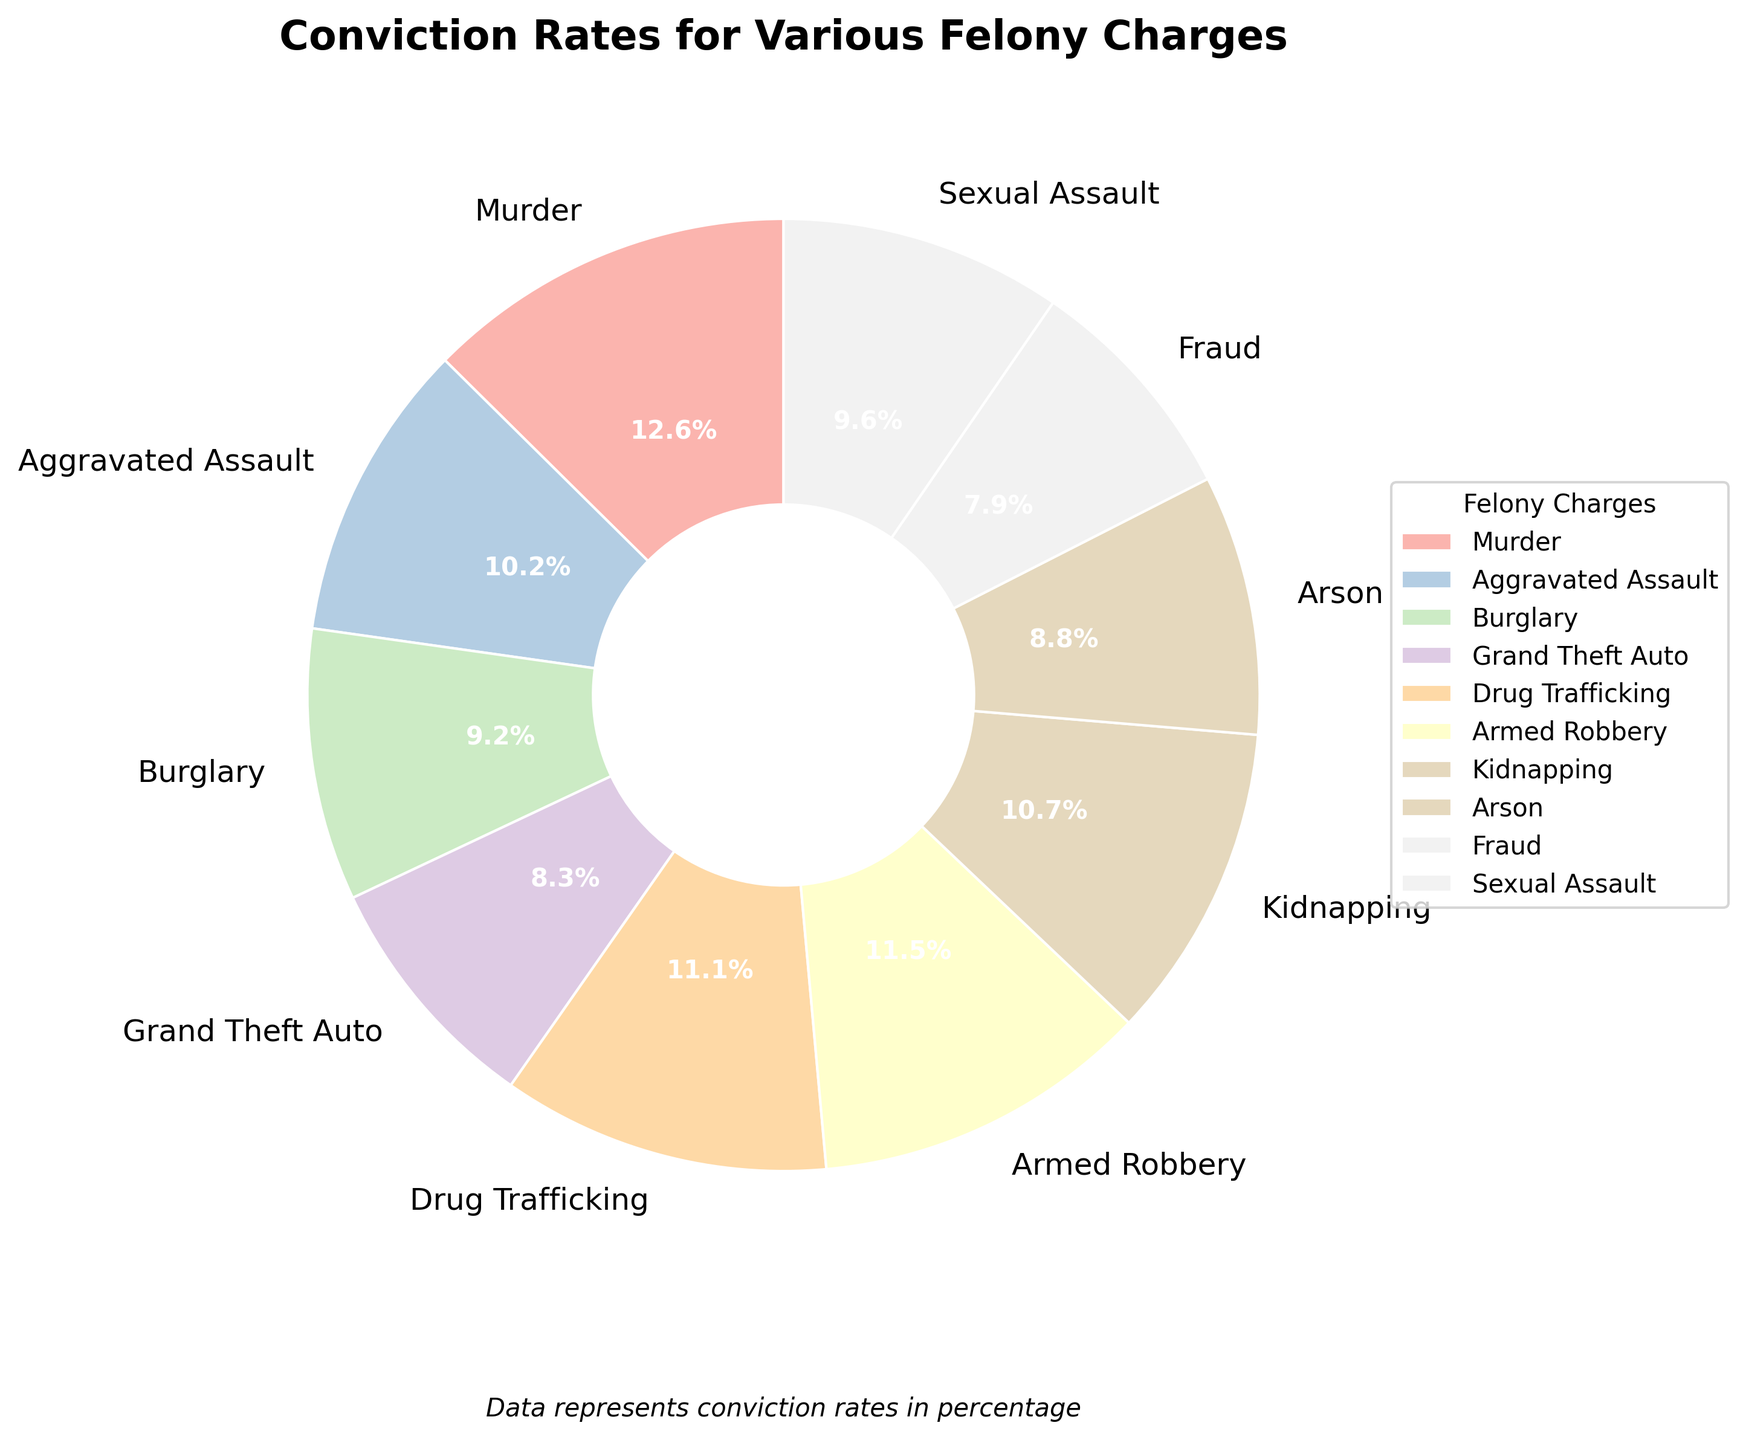What is the total conviction rate for Aggravated Assault and Arson combined? To find the total conviction rate for Aggravated Assault and Arson, look at the conviction rates for both charges (72.3% and 62.8%, respectively) and add them together. Therefore, 72.3 + 62.8 = 135.1.
Answer: 135.1 Which felony charge has the highest conviction rate? To identify the felony charge with the highest conviction rate, look at the pie chart and spot the largest wedge. The wedge corresponding to Murder is the largest, which has a rate of 89.5%.
Answer: Murder Comparing Armed Robbery and Fraud, which has a higher conviction rate? Look at the conviction rates of Armed Robbery (81.6%) and Fraud (56.3%) in the pie chart. Since 81.6 is greater than 56.3, Armed Robbery has the higher conviction rate.
Answer: Armed Robbery What is the difference in conviction rates between Drug Trafficking and Grand Theft Auto? Find the conviction rates for Drug Trafficking (79.2%) and Grand Theft Auto (58.9%), and subtract the latter from the former. The difference is 79.2 - 58.9 = 20.3.
Answer: 20.3 How many felony charges have a conviction rate above 70%? Count the slices that represent conviction rates above 70%, looking at their attached percentages. These include Murder (89.5%), Aggravated Assault (72.3%), Drug Trafficking (79.2%), Armed Robbery (81.6%), and Kidnapping (76.4%). There are 5 such charges.
Answer: 5 What is the average conviction rate for Burglary, Grand Theft Auto, and Arson? Sum the conviction rates for Burglary (65.7%), Grand Theft Auto (58.9%), and Arson (62.8%), then divide by the number of charges. The calculation is (65.7 + 58.9 + 62.8) / 3 = 187.4 / 3 ≈ 62.47.
Answer: 62.47 Which felony charge is represented by a purple wedge in the pie chart? Visually scan the pie chart for the purple wedge and then identify the corresponding label. In the given plot, the purple wedge represents Fraud.
Answer: Fraud Is the conviction rate for Sexual Assault greater than the combined rate for Fraud and Grand Theft Auto? Compare the conviction rate for Sexual Assault (68.1%) to the combined rates of Fraud (56.3%) and Grand Theft Auto (58.9%). Add the latter two: 56.3 + 58.9 = 115.2. Since 68.1 is not greater than 115.2, the answer is no.
Answer: No 